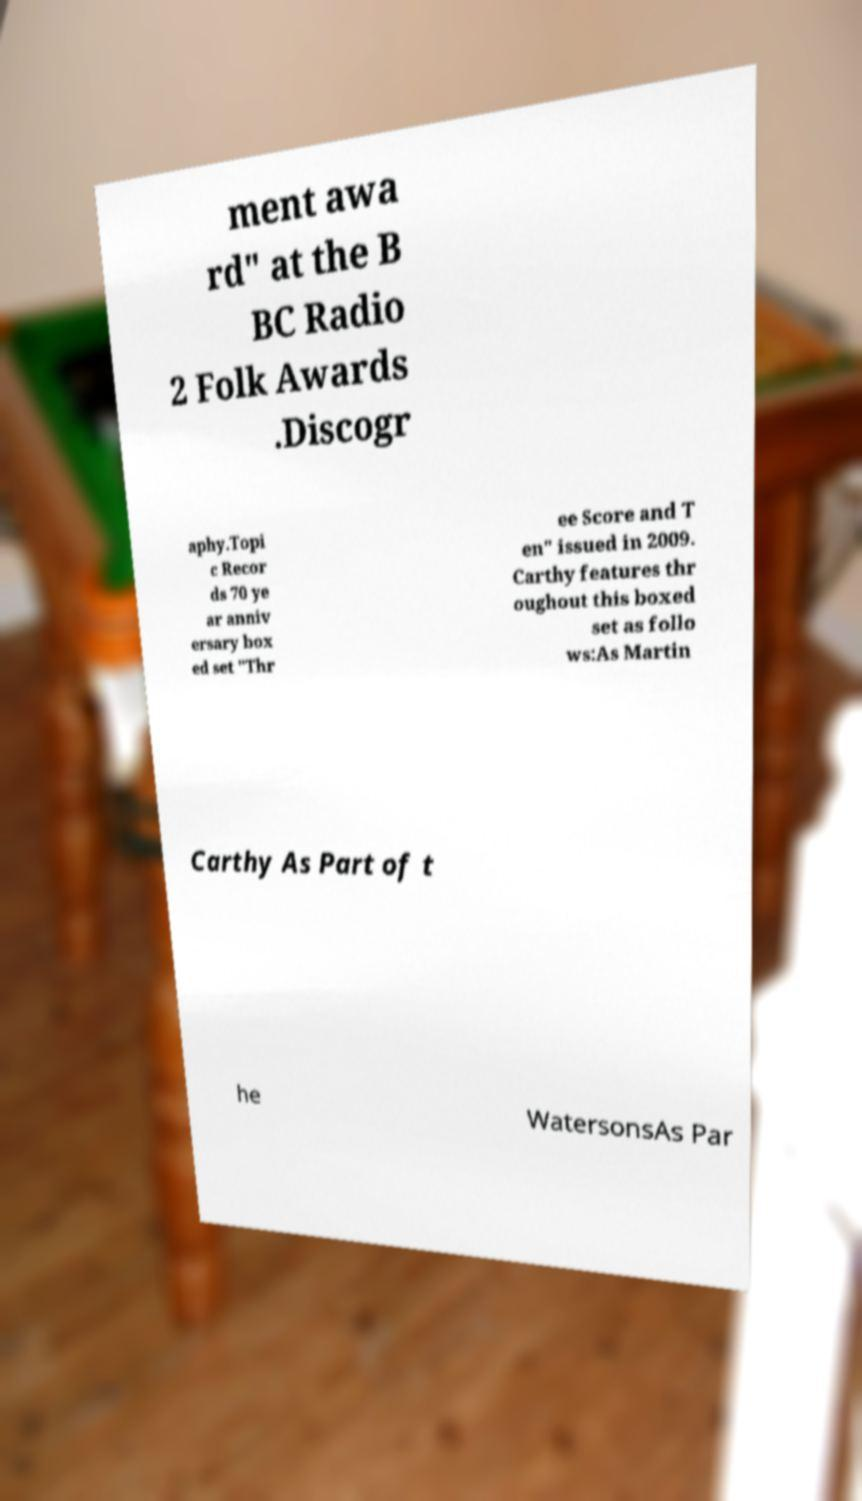Please identify and transcribe the text found in this image. ment awa rd" at the B BC Radio 2 Folk Awards .Discogr aphy.Topi c Recor ds 70 ye ar anniv ersary box ed set "Thr ee Score and T en" issued in 2009. Carthy features thr oughout this boxed set as follo ws:As Martin Carthy As Part of t he WatersonsAs Par 